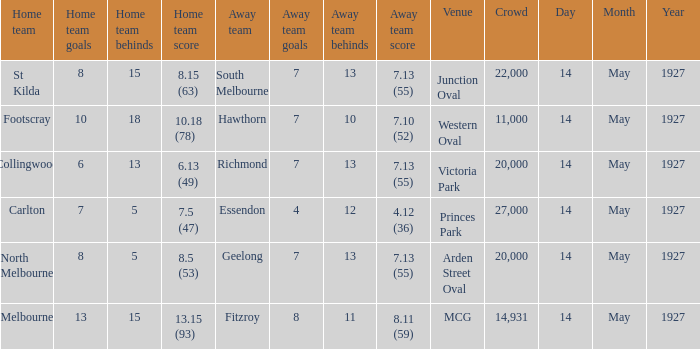What was the home team when the Geelong away team had a score of 7.13 (55)? North Melbourne. 